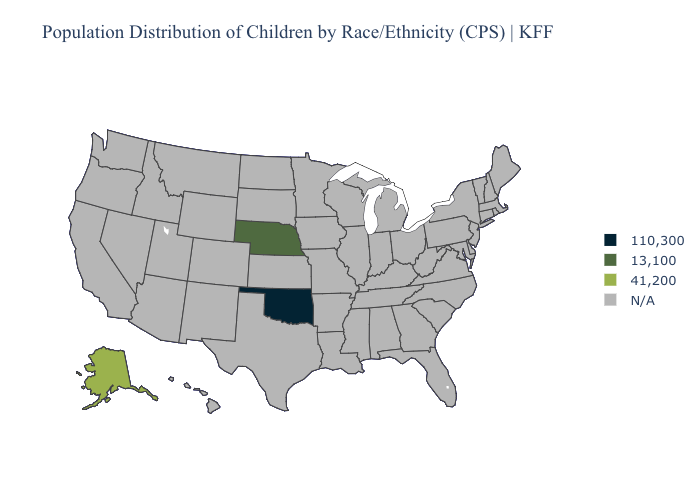Name the states that have a value in the range N/A?
Keep it brief. Alabama, Arizona, Arkansas, California, Colorado, Connecticut, Delaware, Florida, Georgia, Hawaii, Idaho, Illinois, Indiana, Iowa, Kansas, Kentucky, Louisiana, Maine, Maryland, Massachusetts, Michigan, Minnesota, Mississippi, Missouri, Montana, Nevada, New Hampshire, New Jersey, New Mexico, New York, North Carolina, North Dakota, Ohio, Oregon, Pennsylvania, Rhode Island, South Carolina, South Dakota, Tennessee, Texas, Utah, Vermont, Virginia, Washington, West Virginia, Wisconsin, Wyoming. What is the value of Iowa?
Quick response, please. N/A. What is the lowest value in the South?
Quick response, please. 110,300. Name the states that have a value in the range 13,100?
Quick response, please. Nebraska. Is the legend a continuous bar?
Be succinct. No. How many symbols are there in the legend?
Give a very brief answer. 4. Which states have the lowest value in the South?
Concise answer only. Oklahoma. Which states have the lowest value in the South?
Answer briefly. Oklahoma. What is the value of Wisconsin?
Give a very brief answer. N/A. What is the highest value in the MidWest ?
Concise answer only. 13,100. Name the states that have a value in the range 13,100?
Give a very brief answer. Nebraska. 